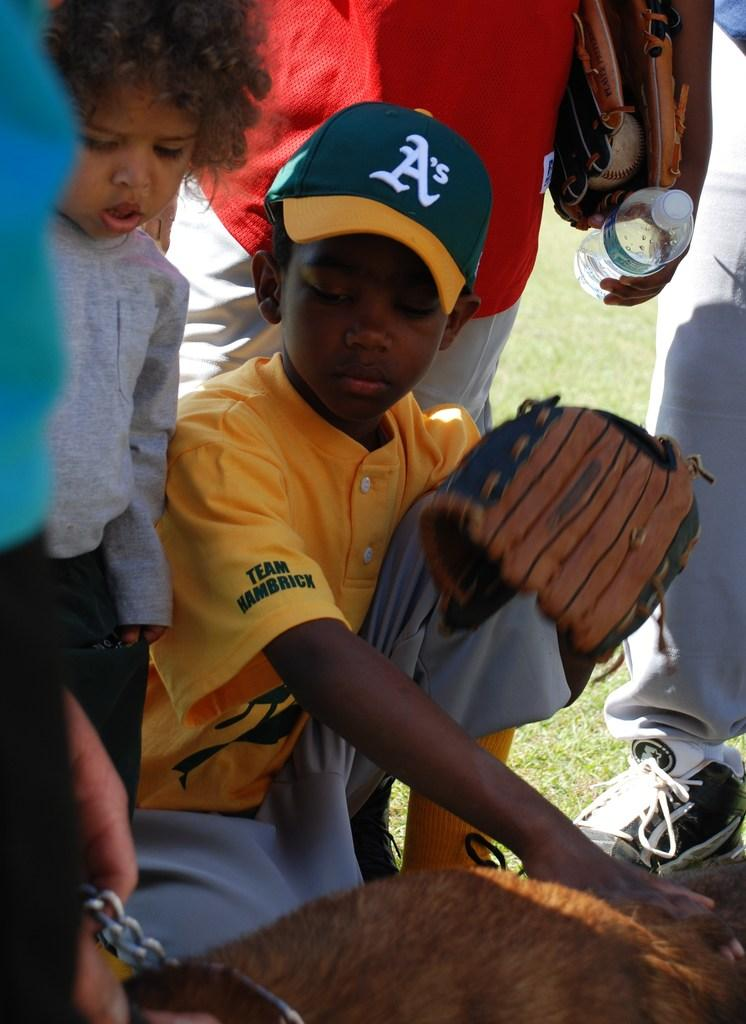<image>
Present a compact description of the photo's key features. A small boy wearing a top with team hambrick on it looks at a dog. 